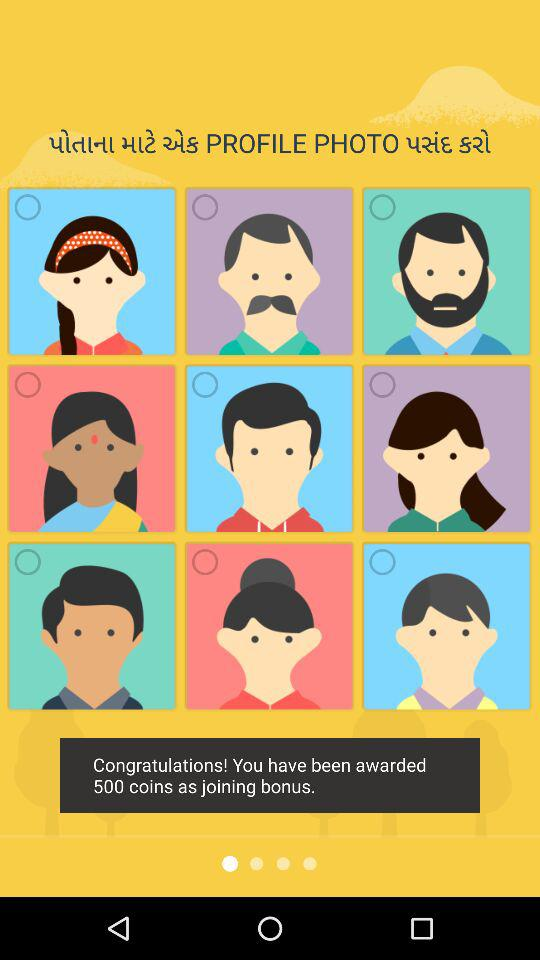How many coins did the user earn as joining bonus?
Answer the question using a single word or phrase. 500 